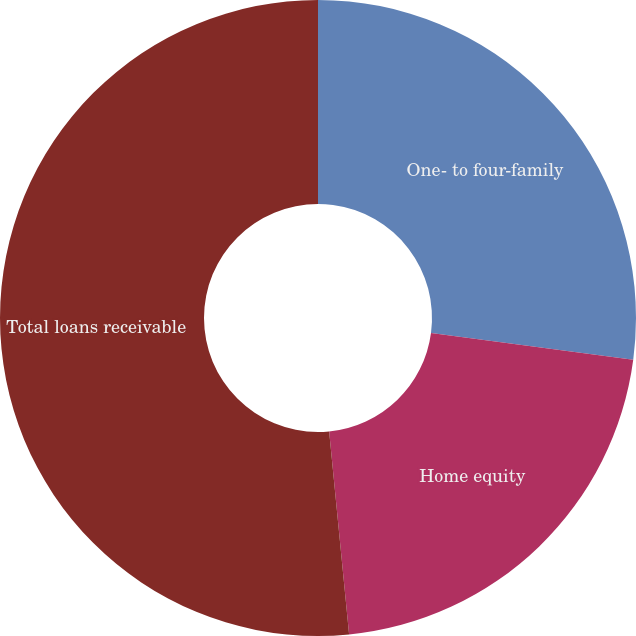Convert chart to OTSL. <chart><loc_0><loc_0><loc_500><loc_500><pie_chart><fcel>One- to four-family<fcel>Home equity<fcel>Total loans receivable<nl><fcel>27.1%<fcel>21.34%<fcel>51.56%<nl></chart> 